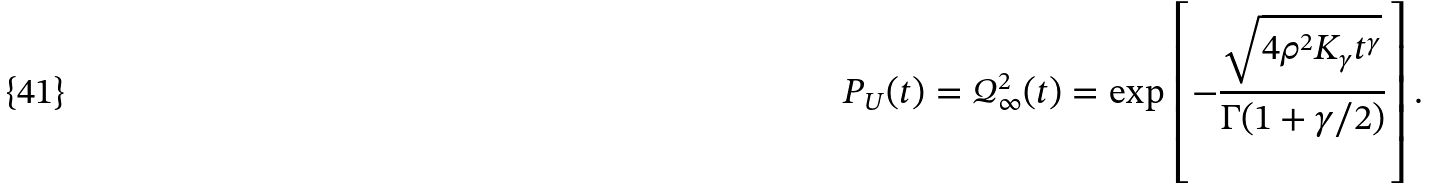<formula> <loc_0><loc_0><loc_500><loc_500>P _ { U } ( t ) = { \mathcal { Q } } _ { \infty } ^ { 2 } ( t ) = \exp \left [ - \frac { \sqrt { 4 \rho ^ { 2 } K _ { \gamma } t ^ { \gamma } } } { \Gamma ( 1 + \gamma / 2 ) } \right ] .</formula> 